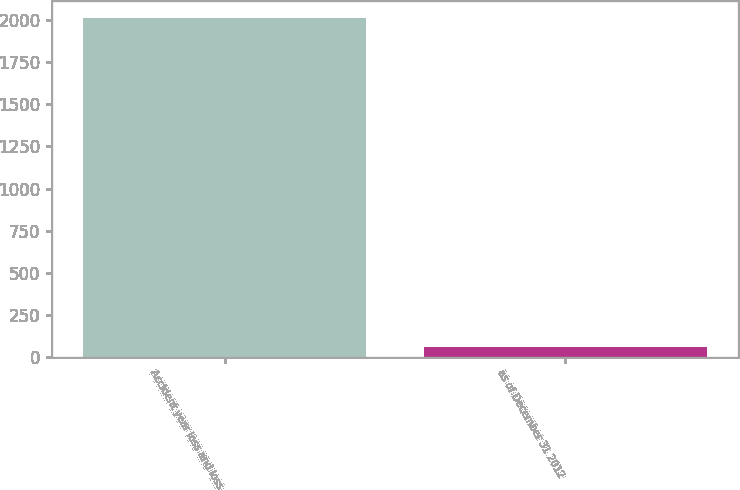<chart> <loc_0><loc_0><loc_500><loc_500><bar_chart><fcel>Accident year loss and loss<fcel>as of December 31 2012<nl><fcel>2012<fcel>59.9<nl></chart> 